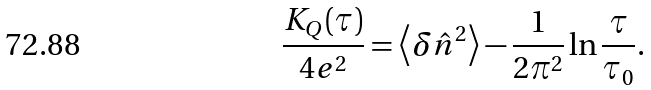Convert formula to latex. <formula><loc_0><loc_0><loc_500><loc_500>\frac { K _ { Q } ( \tau ) } { 4 e ^ { 2 } } = \left < \delta \hat { n } ^ { 2 } \right > - \frac { 1 } { 2 \pi ^ { 2 } } \ln \frac { \tau } { \tau _ { 0 } } .</formula> 